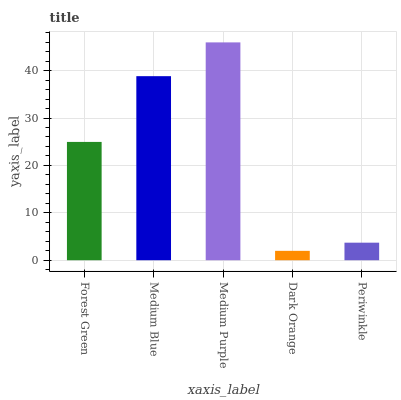Is Dark Orange the minimum?
Answer yes or no. Yes. Is Medium Purple the maximum?
Answer yes or no. Yes. Is Medium Blue the minimum?
Answer yes or no. No. Is Medium Blue the maximum?
Answer yes or no. No. Is Medium Blue greater than Forest Green?
Answer yes or no. Yes. Is Forest Green less than Medium Blue?
Answer yes or no. Yes. Is Forest Green greater than Medium Blue?
Answer yes or no. No. Is Medium Blue less than Forest Green?
Answer yes or no. No. Is Forest Green the high median?
Answer yes or no. Yes. Is Forest Green the low median?
Answer yes or no. Yes. Is Medium Purple the high median?
Answer yes or no. No. Is Periwinkle the low median?
Answer yes or no. No. 